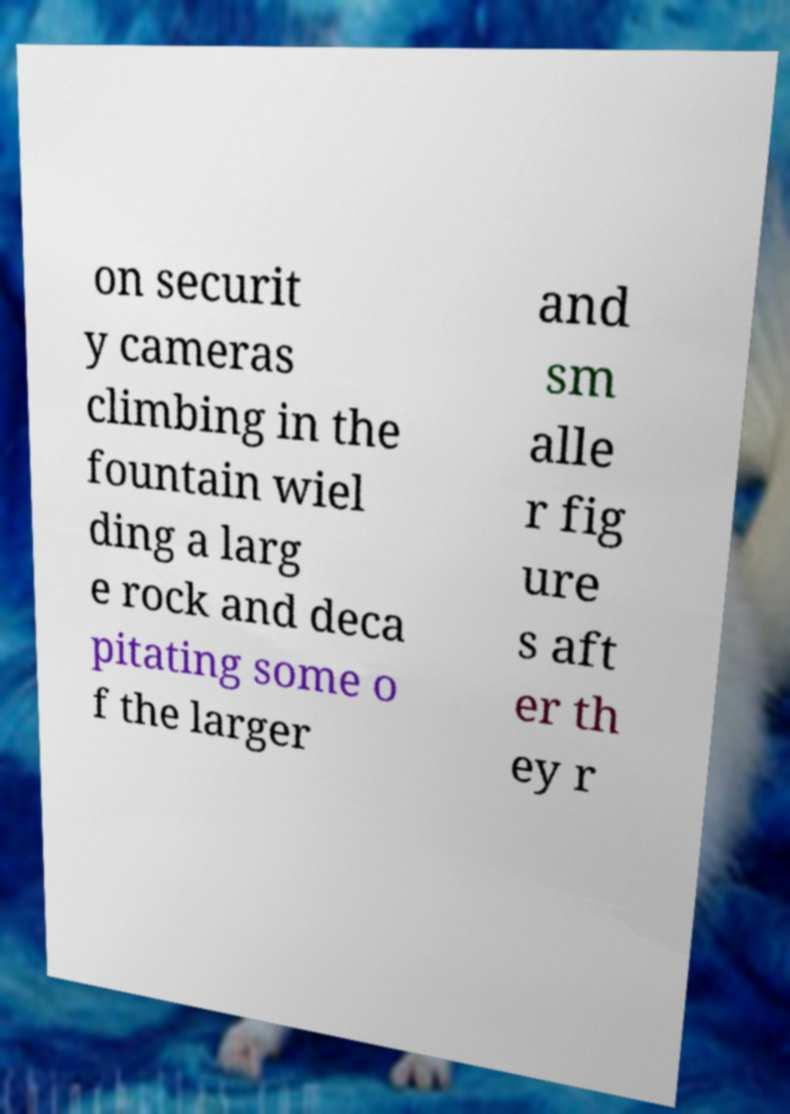For documentation purposes, I need the text within this image transcribed. Could you provide that? on securit y cameras climbing in the fountain wiel ding a larg e rock and deca pitating some o f the larger and sm alle r fig ure s aft er th ey r 